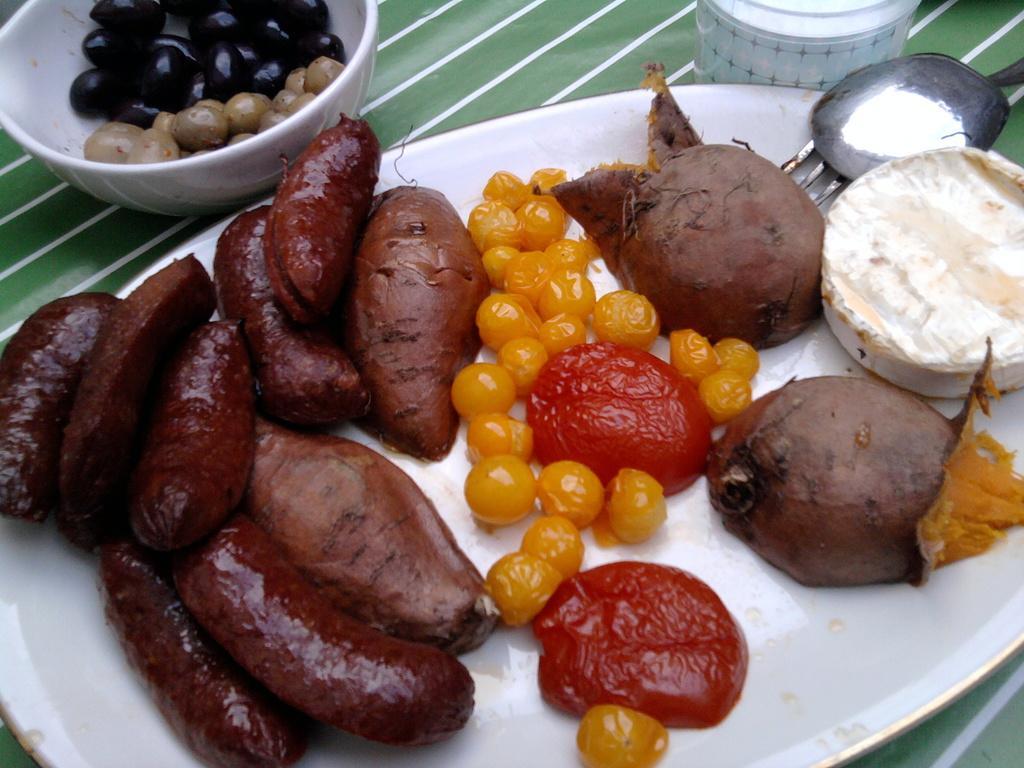In one or two sentences, can you explain what this image depicts? In this picture we can observe some vegetables and fruits placed in the white color plate. They are in different colors. We can observe maroon, red, yellow and brown colors. On the left side we can observe a bowl in which there are some fruits. These are placed on the table. On the right side there is a spoon and a fork. 